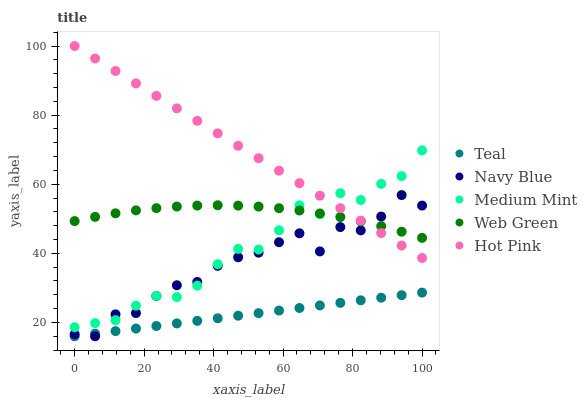Does Teal have the minimum area under the curve?
Answer yes or no. Yes. Does Hot Pink have the maximum area under the curve?
Answer yes or no. Yes. Does Navy Blue have the minimum area under the curve?
Answer yes or no. No. Does Navy Blue have the maximum area under the curve?
Answer yes or no. No. Is Teal the smoothest?
Answer yes or no. Yes. Is Navy Blue the roughest?
Answer yes or no. Yes. Is Hot Pink the smoothest?
Answer yes or no. No. Is Hot Pink the roughest?
Answer yes or no. No. Does Navy Blue have the lowest value?
Answer yes or no. Yes. Does Hot Pink have the lowest value?
Answer yes or no. No. Does Hot Pink have the highest value?
Answer yes or no. Yes. Does Navy Blue have the highest value?
Answer yes or no. No. Is Teal less than Hot Pink?
Answer yes or no. Yes. Is Web Green greater than Teal?
Answer yes or no. Yes. Does Navy Blue intersect Hot Pink?
Answer yes or no. Yes. Is Navy Blue less than Hot Pink?
Answer yes or no. No. Is Navy Blue greater than Hot Pink?
Answer yes or no. No. Does Teal intersect Hot Pink?
Answer yes or no. No. 